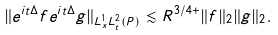Convert formula to latex. <formula><loc_0><loc_0><loc_500><loc_500>\| e ^ { i t \Delta } f e ^ { i t \Delta } g \| _ { L ^ { 1 } _ { x } L ^ { 2 } _ { t } ( P ) } \lesssim R ^ { 3 / 4 + } \| f \| _ { 2 } \| g \| _ { 2 } .</formula> 